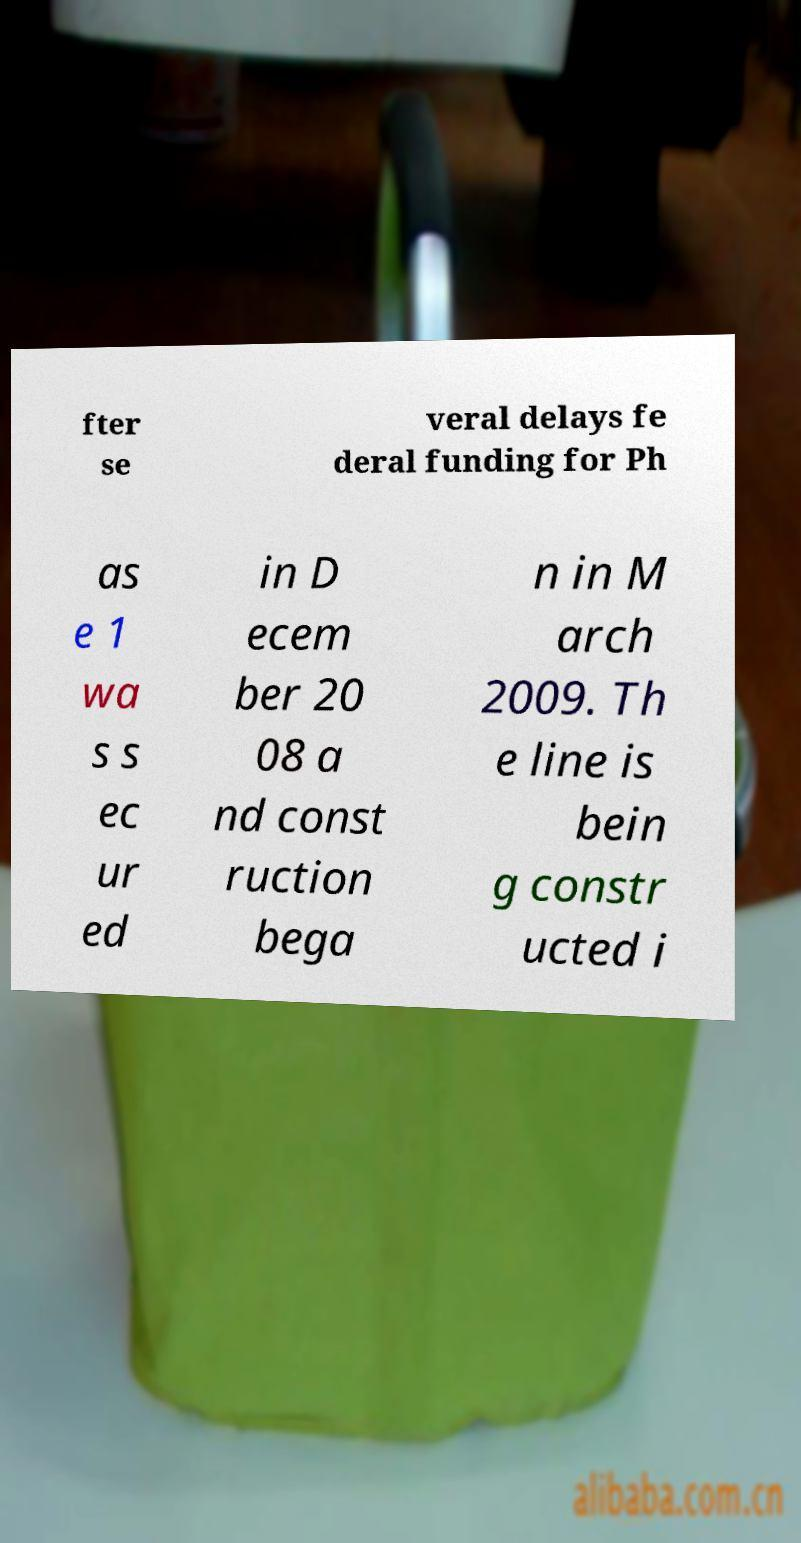Could you extract and type out the text from this image? fter se veral delays fe deral funding for Ph as e 1 wa s s ec ur ed in D ecem ber 20 08 a nd const ruction bega n in M arch 2009. Th e line is bein g constr ucted i 